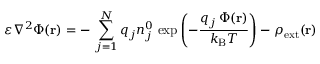<formula> <loc_0><loc_0><loc_500><loc_500>\varepsilon \nabla ^ { 2 } \Phi ( r ) = - \, \sum _ { j = 1 } ^ { N } q _ { j } n _ { j } ^ { 0 } \, \exp \left ( - { \frac { q _ { j } \, \Phi ( r ) } { k _ { B } T } } \right ) - \rho _ { e x t } ( r )</formula> 